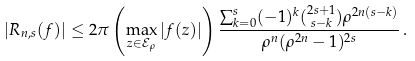<formula> <loc_0><loc_0><loc_500><loc_500>\left | R _ { n , s } ( f ) \right | \leq 2 \pi \left ( \max _ { z \in \mathcal { E } _ { \rho } } | f ( z ) | \right ) \frac { \sum _ { k = 0 } ^ { s } ( - 1 ) ^ { k } { 2 s + 1 \choose s - k } \rho ^ { 2 n ( s - k ) } } { \rho ^ { n } ( \rho ^ { 2 n } - 1 ) ^ { 2 s } } \, .</formula> 